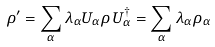Convert formula to latex. <formula><loc_0><loc_0><loc_500><loc_500>\rho ^ { \prime } = \sum _ { \alpha } \lambda _ { \alpha } U _ { \alpha } \rho \, U _ { \alpha } ^ { \dagger } = \sum _ { \alpha } \lambda _ { \alpha } \rho _ { \alpha }</formula> 